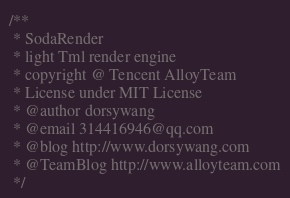Convert code to text. <code><loc_0><loc_0><loc_500><loc_500><_JavaScript_>/**
 * SodaRender
 * light Tml render engine
 * copyright @ Tencent AlloyTeam
 * License under MIT License
 * @author dorsywang
 * @email 314416946@qq.com
 * @blog http://www.dorsywang.com
 * @TeamBlog http://www.alloyteam.com
 */</code> 